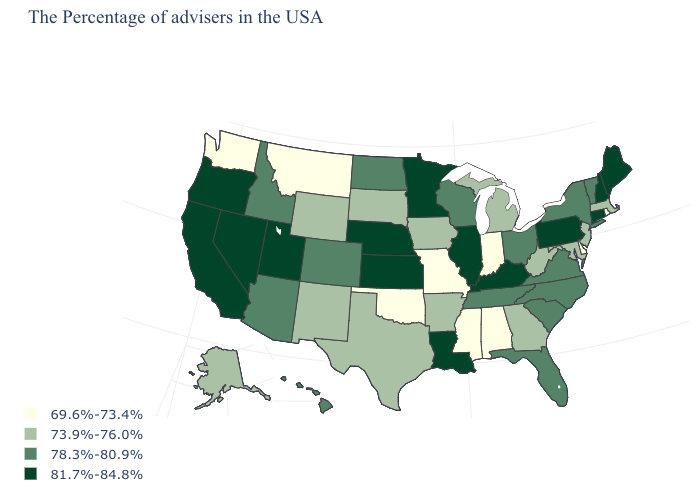What is the value of Oregon?
Short answer required. 81.7%-84.8%. Which states have the lowest value in the West?
Concise answer only. Montana, Washington. Name the states that have a value in the range 69.6%-73.4%?
Concise answer only. Rhode Island, Delaware, Indiana, Alabama, Mississippi, Missouri, Oklahoma, Montana, Washington. Name the states that have a value in the range 69.6%-73.4%?
Concise answer only. Rhode Island, Delaware, Indiana, Alabama, Mississippi, Missouri, Oklahoma, Montana, Washington. Among the states that border Tennessee , which have the highest value?
Keep it brief. Kentucky. Does Hawaii have the lowest value in the USA?
Short answer required. No. Among the states that border Vermont , which have the highest value?
Give a very brief answer. New Hampshire. Name the states that have a value in the range 73.9%-76.0%?
Write a very short answer. Massachusetts, New Jersey, Maryland, West Virginia, Georgia, Michigan, Arkansas, Iowa, Texas, South Dakota, Wyoming, New Mexico, Alaska. Is the legend a continuous bar?
Quick response, please. No. What is the lowest value in states that border Maryland?
Short answer required. 69.6%-73.4%. Name the states that have a value in the range 81.7%-84.8%?
Answer briefly. Maine, New Hampshire, Connecticut, Pennsylvania, Kentucky, Illinois, Louisiana, Minnesota, Kansas, Nebraska, Utah, Nevada, California, Oregon. Name the states that have a value in the range 69.6%-73.4%?
Give a very brief answer. Rhode Island, Delaware, Indiana, Alabama, Mississippi, Missouri, Oklahoma, Montana, Washington. Does New Hampshire have a lower value than Ohio?
Give a very brief answer. No. Name the states that have a value in the range 69.6%-73.4%?
Give a very brief answer. Rhode Island, Delaware, Indiana, Alabama, Mississippi, Missouri, Oklahoma, Montana, Washington. Does Wisconsin have the lowest value in the USA?
Write a very short answer. No. 